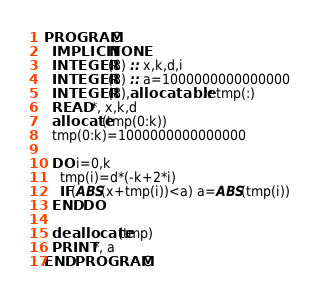<code> <loc_0><loc_0><loc_500><loc_500><_FORTRAN_>PROGRAM C
  IMPLICIT NONE
  INTEGER(8) :: x,k,d,i
  INTEGER(8) :: a=1000000000000000
  INTEGER(8),allocatable :: tmp(:)
  READ *, x,k,d
  allocate(tmp(0:k))
  tmp(0:k)=1000000000000000

  DO i=0,k
    tmp(i)=d*(-k+2*i)
    IF(ABS(x+tmp(i))<a) a=ABS(tmp(i))
  END DO

  deallocate(tmp)
  PRINT *, a
END PROGRAM C
</code> 